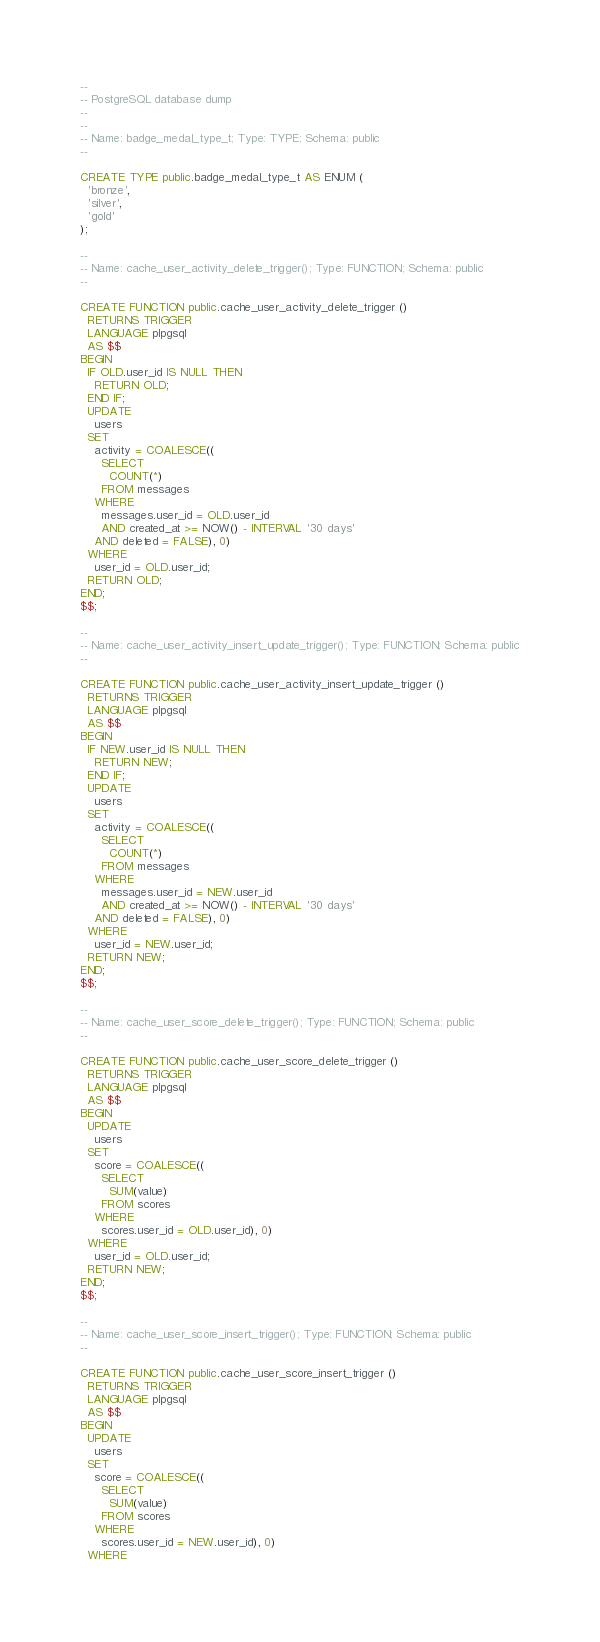<code> <loc_0><loc_0><loc_500><loc_500><_SQL_>--
-- PostgreSQL database dump
--
--
-- Name: badge_medal_type_t; Type: TYPE; Schema: public
--

CREATE TYPE public.badge_medal_type_t AS ENUM (
  'bronze',
  'silver',
  'gold'
);

--
-- Name: cache_user_activity_delete_trigger(); Type: FUNCTION; Schema: public
--

CREATE FUNCTION public.cache_user_activity_delete_trigger ()
  RETURNS TRIGGER
  LANGUAGE plpgsql
  AS $$
BEGIN
  IF OLD.user_id IS NULL THEN
    RETURN OLD;
  END IF;
  UPDATE
    users
  SET
    activity = COALESCE((
      SELECT
        COUNT(*)
      FROM messages
    WHERE
      messages.user_id = OLD.user_id
      AND created_at >= NOW() - INTERVAL '30 days'
    AND deleted = FALSE), 0)
  WHERE
    user_id = OLD.user_id;
  RETURN OLD;
END;
$$;

--
-- Name: cache_user_activity_insert_update_trigger(); Type: FUNCTION; Schema: public
--

CREATE FUNCTION public.cache_user_activity_insert_update_trigger ()
  RETURNS TRIGGER
  LANGUAGE plpgsql
  AS $$
BEGIN
  IF NEW.user_id IS NULL THEN
    RETURN NEW;
  END IF;
  UPDATE
    users
  SET
    activity = COALESCE((
      SELECT
        COUNT(*)
      FROM messages
    WHERE
      messages.user_id = NEW.user_id
      AND created_at >= NOW() - INTERVAL '30 days'
    AND deleted = FALSE), 0)
  WHERE
    user_id = NEW.user_id;
  RETURN NEW;
END;
$$;

--
-- Name: cache_user_score_delete_trigger(); Type: FUNCTION; Schema: public
--

CREATE FUNCTION public.cache_user_score_delete_trigger ()
  RETURNS TRIGGER
  LANGUAGE plpgsql
  AS $$
BEGIN
  UPDATE
    users
  SET
    score = COALESCE((
      SELECT
        SUM(value)
      FROM scores
    WHERE
      scores.user_id = OLD.user_id), 0)
  WHERE
    user_id = OLD.user_id;
  RETURN NEW;
END;
$$;

--
-- Name: cache_user_score_insert_trigger(); Type: FUNCTION; Schema: public
--

CREATE FUNCTION public.cache_user_score_insert_trigger ()
  RETURNS TRIGGER
  LANGUAGE plpgsql
  AS $$
BEGIN
  UPDATE
    users
  SET
    score = COALESCE((
      SELECT
        SUM(value)
      FROM scores
    WHERE
      scores.user_id = NEW.user_id), 0)
  WHERE</code> 